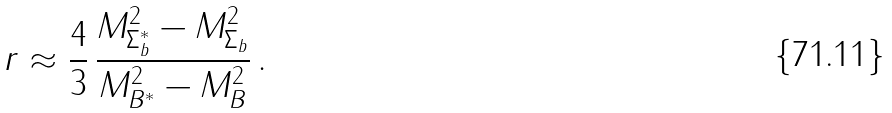<formula> <loc_0><loc_0><loc_500><loc_500>r \approx \frac { 4 } { 3 } \, \frac { M _ { \Sigma _ { b } ^ { * } } ^ { 2 } - M _ { \Sigma _ { b } } ^ { 2 } } { M _ { B ^ { * } } ^ { 2 } - M _ { B } ^ { 2 } } \, .</formula> 